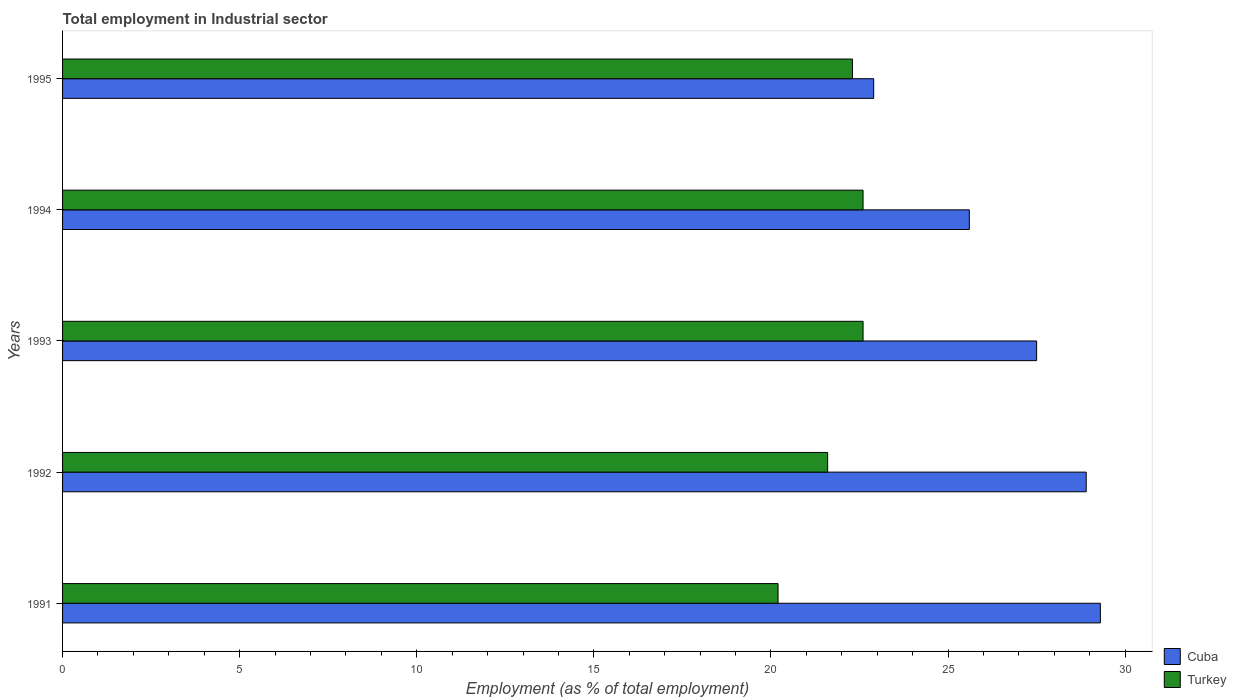How many different coloured bars are there?
Offer a terse response. 2. How many groups of bars are there?
Provide a succinct answer. 5. How many bars are there on the 5th tick from the top?
Give a very brief answer. 2. How many bars are there on the 5th tick from the bottom?
Your answer should be compact. 2. What is the label of the 4th group of bars from the top?
Offer a terse response. 1992. In how many cases, is the number of bars for a given year not equal to the number of legend labels?
Ensure brevity in your answer.  0. What is the employment in industrial sector in Cuba in 1994?
Give a very brief answer. 25.6. Across all years, what is the maximum employment in industrial sector in Cuba?
Provide a succinct answer. 29.3. Across all years, what is the minimum employment in industrial sector in Turkey?
Provide a short and direct response. 20.2. What is the total employment in industrial sector in Cuba in the graph?
Your answer should be very brief. 134.2. What is the difference between the employment in industrial sector in Turkey in 1993 and that in 1995?
Make the answer very short. 0.3. What is the difference between the employment in industrial sector in Turkey in 1992 and the employment in industrial sector in Cuba in 1991?
Provide a succinct answer. -7.7. What is the average employment in industrial sector in Cuba per year?
Offer a terse response. 26.84. In the year 1991, what is the difference between the employment in industrial sector in Turkey and employment in industrial sector in Cuba?
Your answer should be compact. -9.1. In how many years, is the employment in industrial sector in Turkey greater than 16 %?
Offer a very short reply. 5. What is the ratio of the employment in industrial sector in Cuba in 1994 to that in 1995?
Keep it short and to the point. 1.12. Is the employment in industrial sector in Cuba in 1992 less than that in 1993?
Make the answer very short. No. What is the difference between the highest and the second highest employment in industrial sector in Cuba?
Make the answer very short. 0.4. What is the difference between the highest and the lowest employment in industrial sector in Turkey?
Provide a short and direct response. 2.4. In how many years, is the employment in industrial sector in Cuba greater than the average employment in industrial sector in Cuba taken over all years?
Provide a succinct answer. 3. What does the 2nd bar from the top in 1992 represents?
Your response must be concise. Cuba. What does the 1st bar from the bottom in 1993 represents?
Provide a short and direct response. Cuba. Are all the bars in the graph horizontal?
Make the answer very short. Yes. What is the difference between two consecutive major ticks on the X-axis?
Ensure brevity in your answer.  5. Does the graph contain any zero values?
Your answer should be very brief. No. Where does the legend appear in the graph?
Your answer should be compact. Bottom right. How are the legend labels stacked?
Ensure brevity in your answer.  Vertical. What is the title of the graph?
Provide a short and direct response. Total employment in Industrial sector. Does "Kenya" appear as one of the legend labels in the graph?
Keep it short and to the point. No. What is the label or title of the X-axis?
Keep it short and to the point. Employment (as % of total employment). What is the label or title of the Y-axis?
Provide a succinct answer. Years. What is the Employment (as % of total employment) of Cuba in 1991?
Offer a terse response. 29.3. What is the Employment (as % of total employment) of Turkey in 1991?
Your answer should be compact. 20.2. What is the Employment (as % of total employment) of Cuba in 1992?
Keep it short and to the point. 28.9. What is the Employment (as % of total employment) of Turkey in 1992?
Your response must be concise. 21.6. What is the Employment (as % of total employment) in Cuba in 1993?
Make the answer very short. 27.5. What is the Employment (as % of total employment) in Turkey in 1993?
Offer a very short reply. 22.6. What is the Employment (as % of total employment) of Cuba in 1994?
Ensure brevity in your answer.  25.6. What is the Employment (as % of total employment) of Turkey in 1994?
Provide a short and direct response. 22.6. What is the Employment (as % of total employment) in Cuba in 1995?
Provide a succinct answer. 22.9. What is the Employment (as % of total employment) in Turkey in 1995?
Make the answer very short. 22.3. Across all years, what is the maximum Employment (as % of total employment) in Cuba?
Offer a very short reply. 29.3. Across all years, what is the maximum Employment (as % of total employment) in Turkey?
Provide a succinct answer. 22.6. Across all years, what is the minimum Employment (as % of total employment) of Cuba?
Your answer should be very brief. 22.9. Across all years, what is the minimum Employment (as % of total employment) of Turkey?
Provide a short and direct response. 20.2. What is the total Employment (as % of total employment) of Cuba in the graph?
Ensure brevity in your answer.  134.2. What is the total Employment (as % of total employment) of Turkey in the graph?
Ensure brevity in your answer.  109.3. What is the difference between the Employment (as % of total employment) in Cuba in 1991 and that in 1993?
Provide a succinct answer. 1.8. What is the difference between the Employment (as % of total employment) in Cuba in 1991 and that in 1994?
Make the answer very short. 3.7. What is the difference between the Employment (as % of total employment) of Turkey in 1991 and that in 1994?
Provide a succinct answer. -2.4. What is the difference between the Employment (as % of total employment) in Cuba in 1992 and that in 1994?
Your answer should be very brief. 3.3. What is the difference between the Employment (as % of total employment) of Turkey in 1992 and that in 1995?
Your response must be concise. -0.7. What is the difference between the Employment (as % of total employment) of Cuba in 1993 and that in 1994?
Offer a terse response. 1.9. What is the difference between the Employment (as % of total employment) of Turkey in 1993 and that in 1995?
Your answer should be compact. 0.3. What is the difference between the Employment (as % of total employment) in Turkey in 1994 and that in 1995?
Make the answer very short. 0.3. What is the difference between the Employment (as % of total employment) in Cuba in 1991 and the Employment (as % of total employment) in Turkey in 1994?
Provide a short and direct response. 6.7. What is the difference between the Employment (as % of total employment) of Cuba in 1991 and the Employment (as % of total employment) of Turkey in 1995?
Make the answer very short. 7. What is the difference between the Employment (as % of total employment) of Cuba in 1993 and the Employment (as % of total employment) of Turkey in 1994?
Provide a short and direct response. 4.9. What is the difference between the Employment (as % of total employment) of Cuba in 1993 and the Employment (as % of total employment) of Turkey in 1995?
Provide a succinct answer. 5.2. What is the difference between the Employment (as % of total employment) of Cuba in 1994 and the Employment (as % of total employment) of Turkey in 1995?
Make the answer very short. 3.3. What is the average Employment (as % of total employment) in Cuba per year?
Provide a short and direct response. 26.84. What is the average Employment (as % of total employment) in Turkey per year?
Ensure brevity in your answer.  21.86. In the year 1991, what is the difference between the Employment (as % of total employment) of Cuba and Employment (as % of total employment) of Turkey?
Your response must be concise. 9.1. In the year 1992, what is the difference between the Employment (as % of total employment) in Cuba and Employment (as % of total employment) in Turkey?
Your answer should be very brief. 7.3. What is the ratio of the Employment (as % of total employment) in Cuba in 1991 to that in 1992?
Ensure brevity in your answer.  1.01. What is the ratio of the Employment (as % of total employment) of Turkey in 1991 to that in 1992?
Provide a succinct answer. 0.94. What is the ratio of the Employment (as % of total employment) of Cuba in 1991 to that in 1993?
Offer a terse response. 1.07. What is the ratio of the Employment (as % of total employment) of Turkey in 1991 to that in 1993?
Your response must be concise. 0.89. What is the ratio of the Employment (as % of total employment) of Cuba in 1991 to that in 1994?
Offer a very short reply. 1.14. What is the ratio of the Employment (as % of total employment) in Turkey in 1991 to that in 1994?
Your response must be concise. 0.89. What is the ratio of the Employment (as % of total employment) of Cuba in 1991 to that in 1995?
Offer a very short reply. 1.28. What is the ratio of the Employment (as % of total employment) of Turkey in 1991 to that in 1995?
Your answer should be compact. 0.91. What is the ratio of the Employment (as % of total employment) of Cuba in 1992 to that in 1993?
Make the answer very short. 1.05. What is the ratio of the Employment (as % of total employment) of Turkey in 1992 to that in 1993?
Give a very brief answer. 0.96. What is the ratio of the Employment (as % of total employment) in Cuba in 1992 to that in 1994?
Offer a terse response. 1.13. What is the ratio of the Employment (as % of total employment) in Turkey in 1992 to that in 1994?
Your answer should be compact. 0.96. What is the ratio of the Employment (as % of total employment) in Cuba in 1992 to that in 1995?
Your answer should be compact. 1.26. What is the ratio of the Employment (as % of total employment) in Turkey in 1992 to that in 1995?
Offer a very short reply. 0.97. What is the ratio of the Employment (as % of total employment) in Cuba in 1993 to that in 1994?
Your response must be concise. 1.07. What is the ratio of the Employment (as % of total employment) of Turkey in 1993 to that in 1994?
Make the answer very short. 1. What is the ratio of the Employment (as % of total employment) of Cuba in 1993 to that in 1995?
Offer a very short reply. 1.2. What is the ratio of the Employment (as % of total employment) in Turkey in 1993 to that in 1995?
Keep it short and to the point. 1.01. What is the ratio of the Employment (as % of total employment) of Cuba in 1994 to that in 1995?
Offer a terse response. 1.12. What is the ratio of the Employment (as % of total employment) of Turkey in 1994 to that in 1995?
Make the answer very short. 1.01. What is the difference between the highest and the second highest Employment (as % of total employment) of Cuba?
Your answer should be very brief. 0.4. What is the difference between the highest and the lowest Employment (as % of total employment) of Cuba?
Your answer should be very brief. 6.4. 